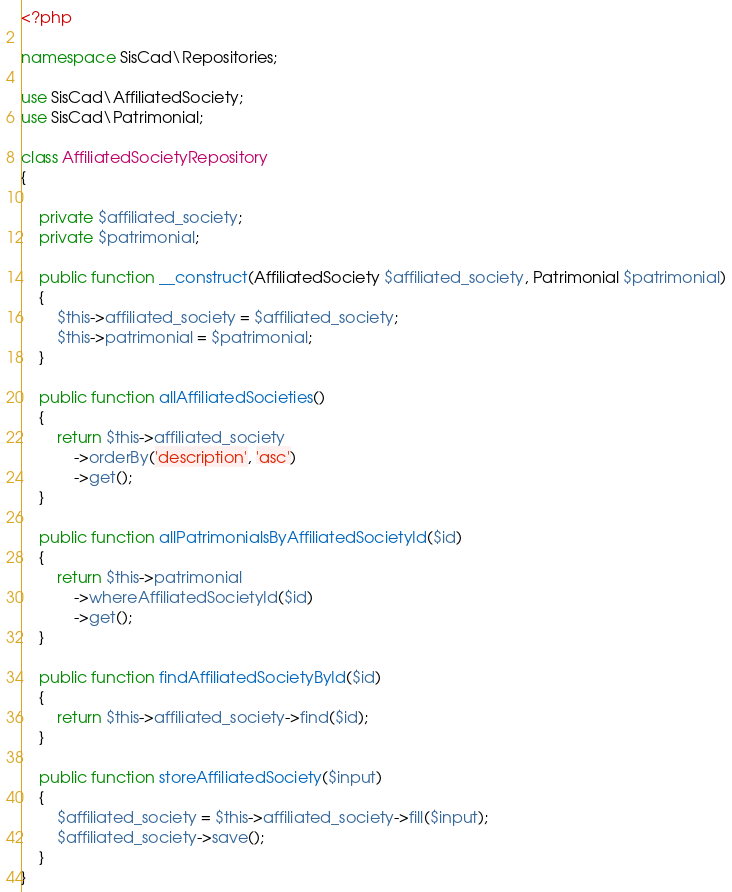<code> <loc_0><loc_0><loc_500><loc_500><_PHP_><?php

namespace SisCad\Repositories;

use SisCad\AffiliatedSociety;
use SisCad\Patrimonial;

class AffiliatedSocietyRepository
{
	
	private $affiliated_society;
	private $patrimonial;

	public function __construct(AffiliatedSociety $affiliated_society, Patrimonial $patrimonial)
	{
		$this->affiliated_society = $affiliated_society;
		$this->patrimonial = $patrimonial;
	}

	public function allAffiliatedSocieties()
	{
		return $this->affiliated_society
			->orderBy('description', 'asc')
			->get();
	}

	public function allPatrimonialsByAffiliatedSocietyId($id)
    {
        return $this->patrimonial
        	->whereAffiliatedSocietyId($id)
        	->get();
    }

    public function findAffiliatedSocietyById($id)
    {
        return $this->affiliated_society->find($id);
    }

    public function storeAffiliatedSociety($input)
    {
        $affiliated_society = $this->affiliated_society->fill($input);
        $affiliated_society->save();
    }
}</code> 